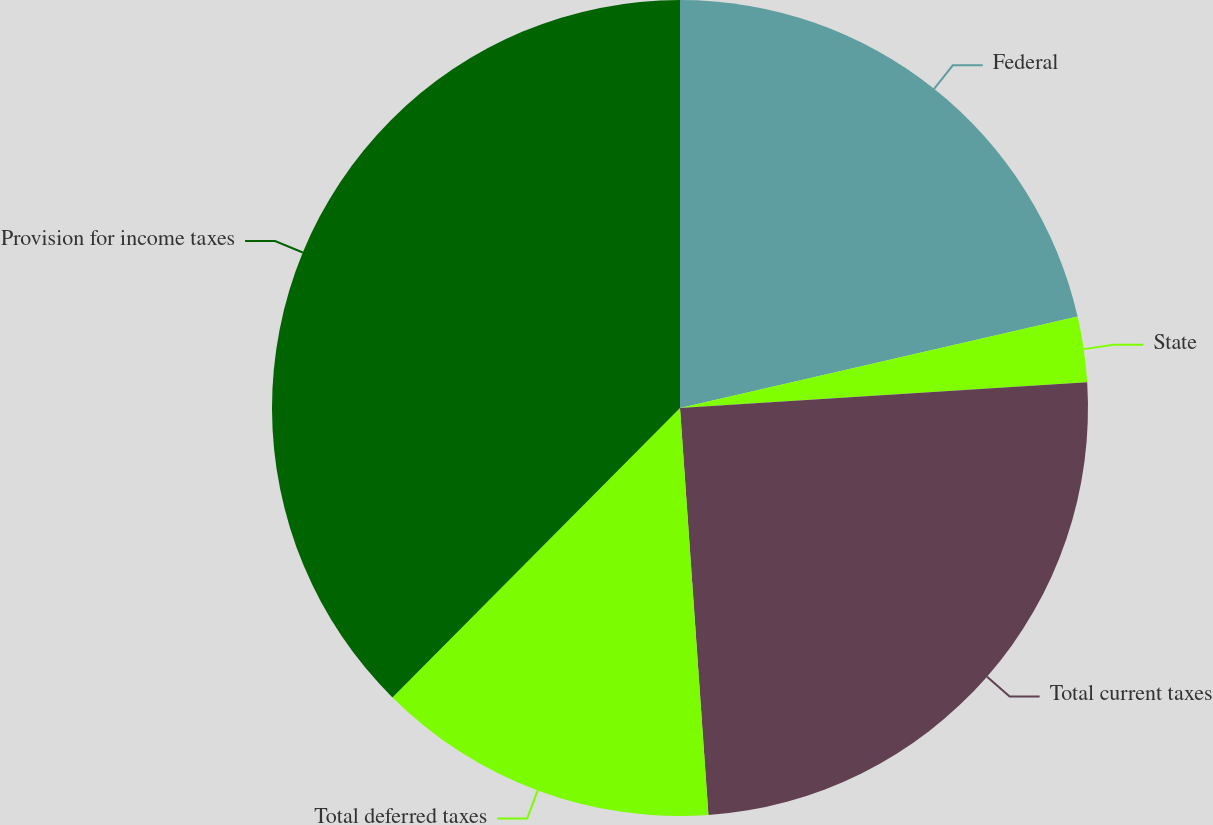<chart> <loc_0><loc_0><loc_500><loc_500><pie_chart><fcel>Federal<fcel>State<fcel>Total current taxes<fcel>Total deferred taxes<fcel>Provision for income taxes<nl><fcel>21.4%<fcel>2.59%<fcel>24.9%<fcel>13.56%<fcel>37.55%<nl></chart> 